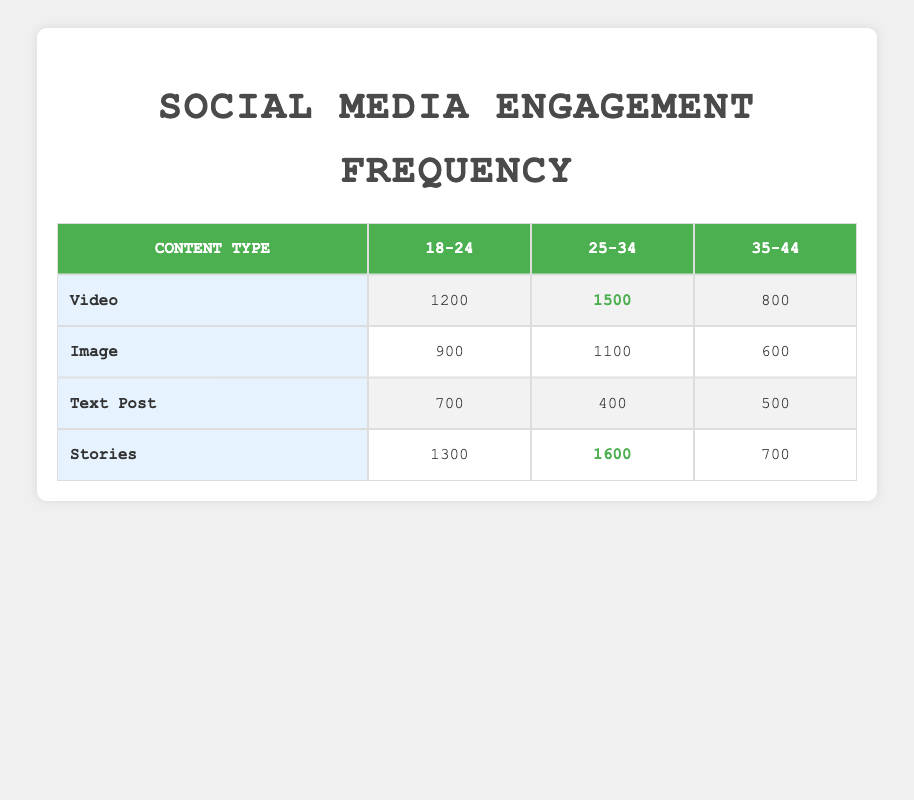What is the highest engagement frequency for video content among the age groups? Looking at the video content row, the engagement frequencies are 1200 for 18-24, 1500 for 25-34, and 800 for 35-44. The highest is 1500 for the 25-34 age group.
Answer: 1500 Which content type has the lowest engagement frequency for the age group 35-44? Checking the 35-44 column for each content type: Video has 800, Image has 600, Text Post has 500, and Stories has 700. The lowest engagement frequency is 500 for Text Post.
Answer: 500 Is the engagement frequency for Stories higher among 25-34 age groups than for Videos? The engagement frequency for Stories in the 25-34 age group is 1600, while for Videos it is 1500. Since 1600 is greater than 1500, the statement is true.
Answer: Yes What is the total engagement frequency for 18-24 age group across all content types? For the 18-24 age group, the engagement frequencies are: Video (1200), Image (900), Text Post (700), and Stories (1300). Adding these gives 1200 + 900 + 700 + 1300 = 4100.
Answer: 4100 Which age group shows the highest engagement frequency for Stories? Looking at the Stories row, the frequencies are 1300 for 18-24, 1600 for 25-34, and 700 for 35-44. The highest engagement frequency is 1600 for the 25-34 age group.
Answer: 1600 What is the average engagement frequency for the 25-34 age group across all content types? The engagement frequencies for 25-34 are: Video (1500), Image (1100), Text Post (400), and Stories (1600). Summing these gives 1500 + 1100 + 400 + 1600 = 3600. Dividing by the number of content types (4) gives an average of 3600 / 4 = 900.
Answer: 900 